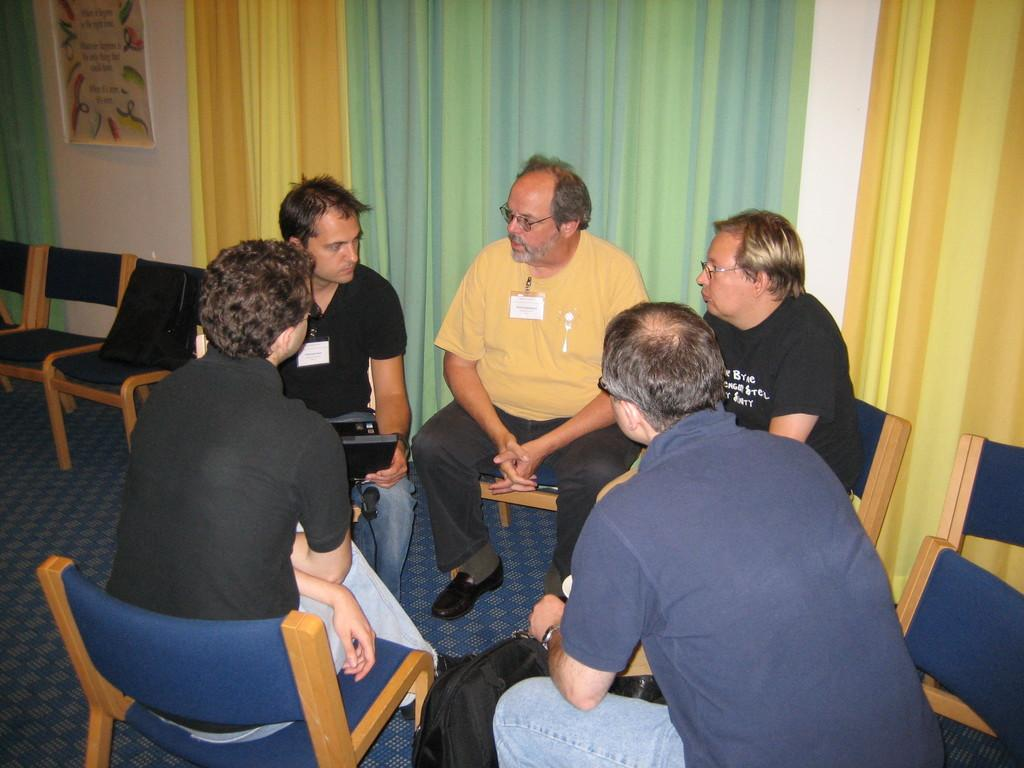How many people are in the image? There are five persons in the image. What are the persons doing in the image? The persons are sitting on chairs. What is visible beneath the persons in the image? There is a floor visible in the image. What object can be seen in the image besides the persons and chairs? There is a bag in the image. What can be seen in the background of the image? There is a curtain and a wall in the background of the image. What type of science experiment is being conducted by the father in the image? There is no father present in the image, and no science experiment is being conducted. 